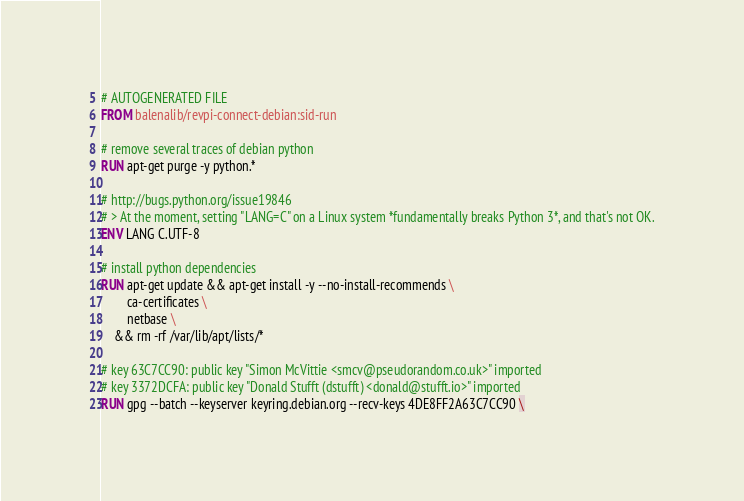Convert code to text. <code><loc_0><loc_0><loc_500><loc_500><_Dockerfile_># AUTOGENERATED FILE
FROM balenalib/revpi-connect-debian:sid-run

# remove several traces of debian python
RUN apt-get purge -y python.*

# http://bugs.python.org/issue19846
# > At the moment, setting "LANG=C" on a Linux system *fundamentally breaks Python 3*, and that's not OK.
ENV LANG C.UTF-8

# install python dependencies
RUN apt-get update && apt-get install -y --no-install-recommends \
		ca-certificates \
		netbase \
	&& rm -rf /var/lib/apt/lists/*

# key 63C7CC90: public key "Simon McVittie <smcv@pseudorandom.co.uk>" imported
# key 3372DCFA: public key "Donald Stufft (dstufft) <donald@stufft.io>" imported
RUN gpg --batch --keyserver keyring.debian.org --recv-keys 4DE8FF2A63C7CC90 \</code> 